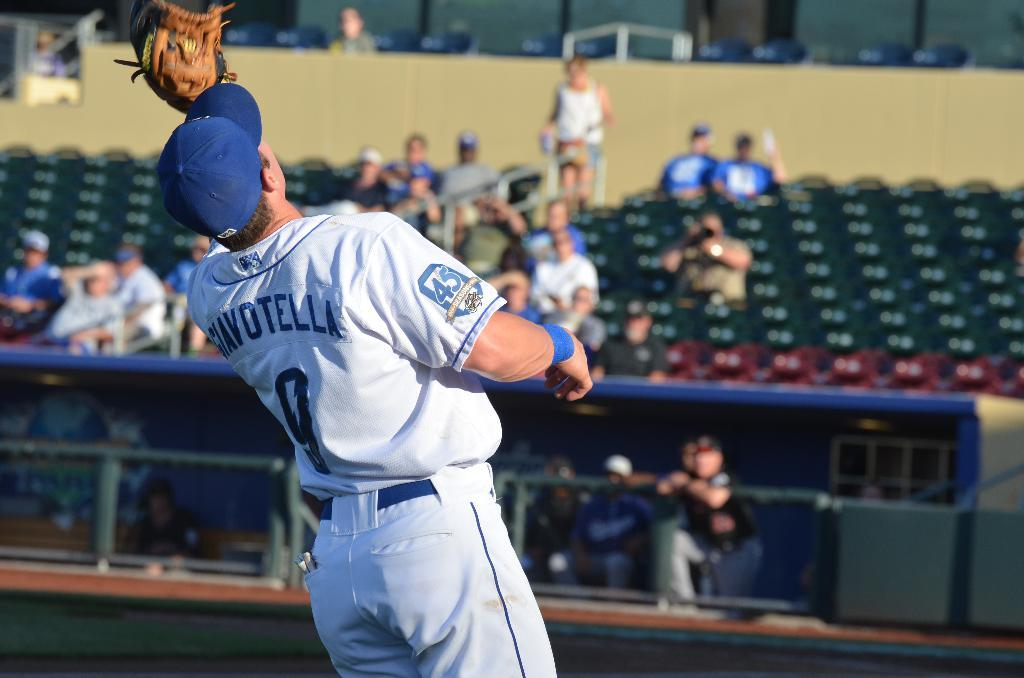<image>
Give a short and clear explanation of the subsequent image. The player wearing number 9 just caught the ball. 